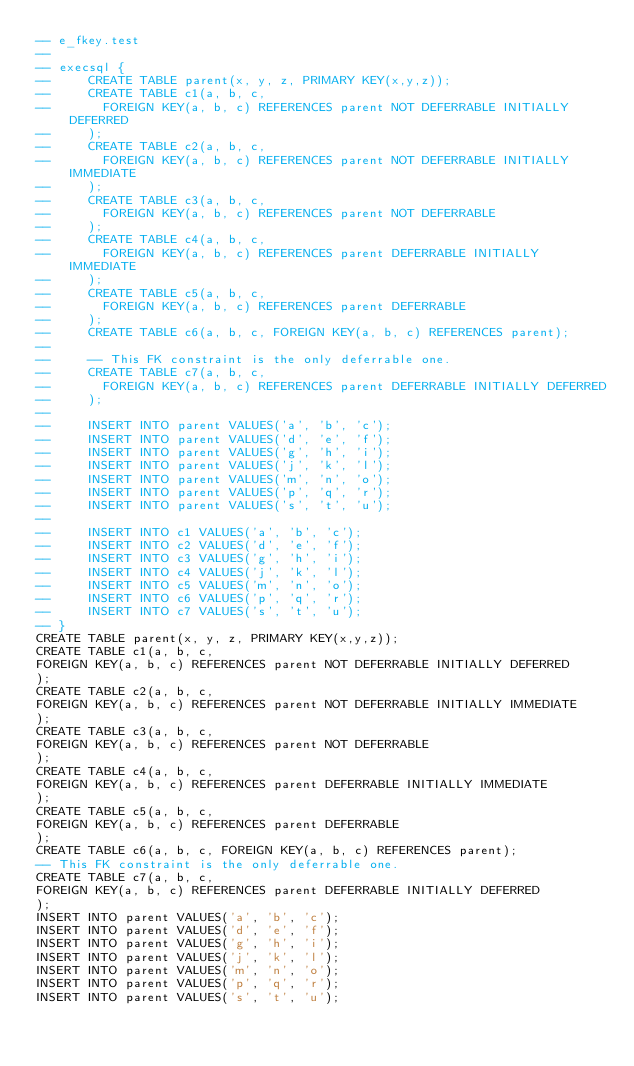<code> <loc_0><loc_0><loc_500><loc_500><_SQL_>-- e_fkey.test
-- 
-- execsql {
--     CREATE TABLE parent(x, y, z, PRIMARY KEY(x,y,z));
--     CREATE TABLE c1(a, b, c,
--       FOREIGN KEY(a, b, c) REFERENCES parent NOT DEFERRABLE INITIALLY DEFERRED
--     );
--     CREATE TABLE c2(a, b, c,
--       FOREIGN KEY(a, b, c) REFERENCES parent NOT DEFERRABLE INITIALLY IMMEDIATE
--     );
--     CREATE TABLE c3(a, b, c,
--       FOREIGN KEY(a, b, c) REFERENCES parent NOT DEFERRABLE
--     );
--     CREATE TABLE c4(a, b, c,
--       FOREIGN KEY(a, b, c) REFERENCES parent DEFERRABLE INITIALLY IMMEDIATE
--     );
--     CREATE TABLE c5(a, b, c,
--       FOREIGN KEY(a, b, c) REFERENCES parent DEFERRABLE
--     );
--     CREATE TABLE c6(a, b, c, FOREIGN KEY(a, b, c) REFERENCES parent);
-- 
--     -- This FK constraint is the only deferrable one.
--     CREATE TABLE c7(a, b, c,
--       FOREIGN KEY(a, b, c) REFERENCES parent DEFERRABLE INITIALLY DEFERRED
--     );
-- 
--     INSERT INTO parent VALUES('a', 'b', 'c');
--     INSERT INTO parent VALUES('d', 'e', 'f');
--     INSERT INTO parent VALUES('g', 'h', 'i');
--     INSERT INTO parent VALUES('j', 'k', 'l');
--     INSERT INTO parent VALUES('m', 'n', 'o');
--     INSERT INTO parent VALUES('p', 'q', 'r');
--     INSERT INTO parent VALUES('s', 't', 'u');
-- 
--     INSERT INTO c1 VALUES('a', 'b', 'c');
--     INSERT INTO c2 VALUES('d', 'e', 'f');
--     INSERT INTO c3 VALUES('g', 'h', 'i');
--     INSERT INTO c4 VALUES('j', 'k', 'l');
--     INSERT INTO c5 VALUES('m', 'n', 'o');
--     INSERT INTO c6 VALUES('p', 'q', 'r');
--     INSERT INTO c7 VALUES('s', 't', 'u');
-- }
CREATE TABLE parent(x, y, z, PRIMARY KEY(x,y,z));
CREATE TABLE c1(a, b, c,
FOREIGN KEY(a, b, c) REFERENCES parent NOT DEFERRABLE INITIALLY DEFERRED
);
CREATE TABLE c2(a, b, c,
FOREIGN KEY(a, b, c) REFERENCES parent NOT DEFERRABLE INITIALLY IMMEDIATE
);
CREATE TABLE c3(a, b, c,
FOREIGN KEY(a, b, c) REFERENCES parent NOT DEFERRABLE
);
CREATE TABLE c4(a, b, c,
FOREIGN KEY(a, b, c) REFERENCES parent DEFERRABLE INITIALLY IMMEDIATE
);
CREATE TABLE c5(a, b, c,
FOREIGN KEY(a, b, c) REFERENCES parent DEFERRABLE
);
CREATE TABLE c6(a, b, c, FOREIGN KEY(a, b, c) REFERENCES parent);
-- This FK constraint is the only deferrable one.
CREATE TABLE c7(a, b, c,
FOREIGN KEY(a, b, c) REFERENCES parent DEFERRABLE INITIALLY DEFERRED
);
INSERT INTO parent VALUES('a', 'b', 'c');
INSERT INTO parent VALUES('d', 'e', 'f');
INSERT INTO parent VALUES('g', 'h', 'i');
INSERT INTO parent VALUES('j', 'k', 'l');
INSERT INTO parent VALUES('m', 'n', 'o');
INSERT INTO parent VALUES('p', 'q', 'r');
INSERT INTO parent VALUES('s', 't', 'u');</code> 